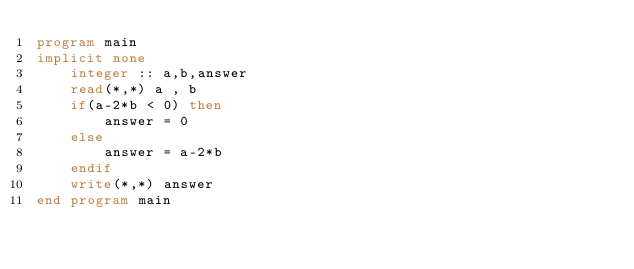<code> <loc_0><loc_0><loc_500><loc_500><_FORTRAN_>program main
implicit none
	integer :: a,b,answer
	read(*,*) a , b
    if(a-2*b < 0) then
    	answer = 0
   	else
    	answer = a-2*b
    endif
    write(*,*) answer
end program main</code> 